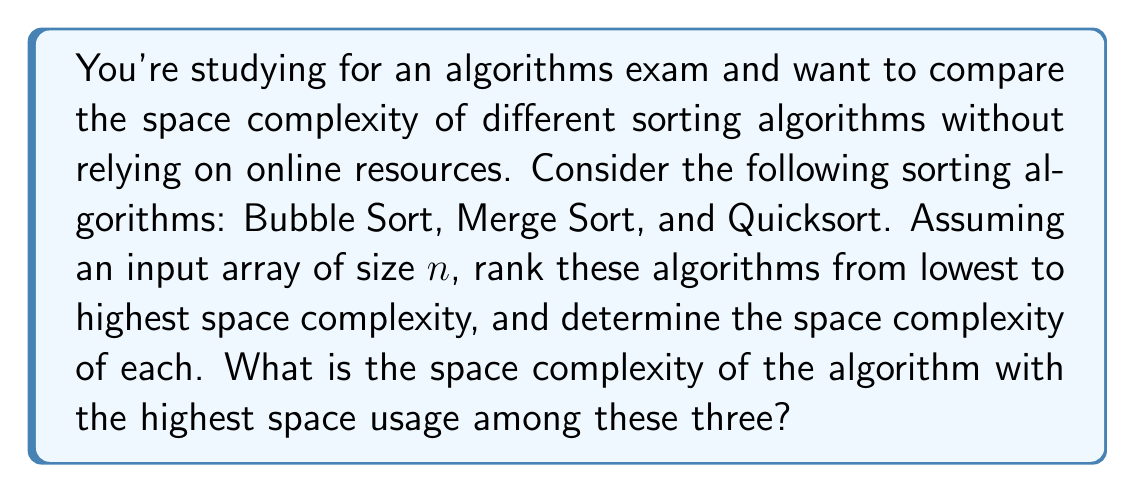Teach me how to tackle this problem. Let's analyze the space complexity of each sorting algorithm:

1. Bubble Sort:
   Bubble sort only requires a constant amount of extra space for the swapping operation.
   Space Complexity: $O(1)$

2. Quicksort:
   In the average case, Quicksort uses $O(\log n)$ extra space for the recursion stack.
   In the worst case (rare), it can use $O(n)$ space.
   Space Complexity: $O(\log n)$ average, $O(n)$ worst case

3. Merge Sort:
   Merge sort requires additional space to store the merged subarrays during the sorting process.
   It typically uses an auxiliary array of size $n$.
   Space Complexity: $O(n)$

Ranking from lowest to highest space complexity:
1. Bubble Sort: $O(1)$
2. Quicksort: $O(\log n)$ average, $O(n)$ worst case
3. Merge Sort: $O(n)$

The algorithm with the highest space usage among these three is Merge Sort, with a space complexity of $O(n)$.
Answer: The space complexity of the algorithm with the highest space usage among Bubble Sort, Merge Sort, and Quicksort is $O(n)$, which corresponds to Merge Sort. 